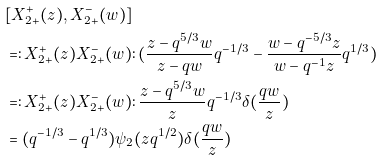Convert formula to latex. <formula><loc_0><loc_0><loc_500><loc_500>& [ X ^ { + } _ { 2 + } ( z ) , X ^ { - } _ { 2 + } ( w ) ] \\ & = \colon X ^ { + } _ { 2 + } ( z ) X ^ { - } _ { 2 + } ( w ) \colon ( \frac { z - q ^ { 5 / 3 } w } { z - q w } q ^ { - 1 / 3 } - \frac { w - q ^ { - 5 / 3 } z } { w - q ^ { - 1 } z } q ^ { 1 / 3 } ) \\ & = \colon X ^ { + } _ { 2 + } ( z ) X ^ { - } _ { 2 + } ( w ) \colon \frac { z - q ^ { 5 / 3 } w } { z } q ^ { - 1 / 3 } \delta ( \frac { q w } z ) \\ & = ( q ^ { - 1 / 3 } - q ^ { 1 / 3 } ) \psi _ { 2 } ( z q ^ { 1 / 2 } ) \delta ( \frac { q w } z )</formula> 